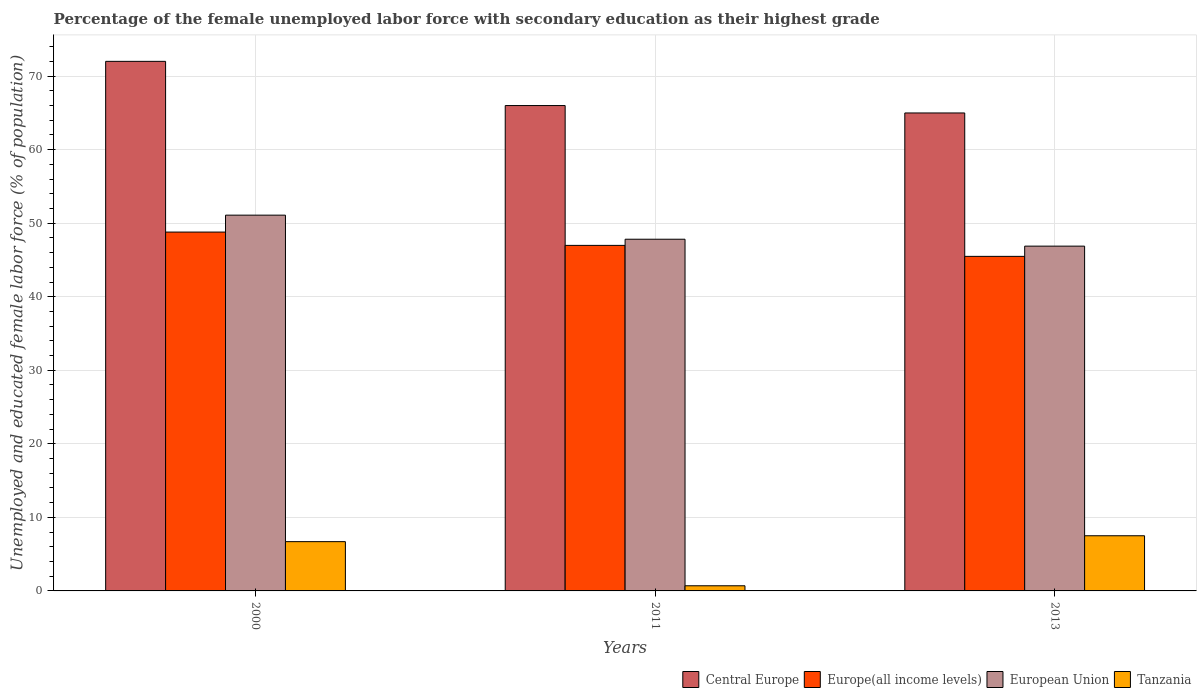How many groups of bars are there?
Ensure brevity in your answer.  3. Are the number of bars per tick equal to the number of legend labels?
Keep it short and to the point. Yes. How many bars are there on the 2nd tick from the left?
Give a very brief answer. 4. How many bars are there on the 1st tick from the right?
Offer a terse response. 4. What is the label of the 3rd group of bars from the left?
Keep it short and to the point. 2013. In how many cases, is the number of bars for a given year not equal to the number of legend labels?
Ensure brevity in your answer.  0. What is the percentage of the unemployed female labor force with secondary education in Tanzania in 2013?
Your response must be concise. 7.5. Across all years, what is the maximum percentage of the unemployed female labor force with secondary education in European Union?
Offer a terse response. 51.09. Across all years, what is the minimum percentage of the unemployed female labor force with secondary education in Tanzania?
Ensure brevity in your answer.  0.7. In which year was the percentage of the unemployed female labor force with secondary education in Europe(all income levels) minimum?
Give a very brief answer. 2013. What is the total percentage of the unemployed female labor force with secondary education in European Union in the graph?
Your answer should be compact. 145.79. What is the difference between the percentage of the unemployed female labor force with secondary education in Central Europe in 2000 and that in 2011?
Your response must be concise. 6.01. What is the difference between the percentage of the unemployed female labor force with secondary education in European Union in 2000 and the percentage of the unemployed female labor force with secondary education in Europe(all income levels) in 2013?
Keep it short and to the point. 5.6. What is the average percentage of the unemployed female labor force with secondary education in Europe(all income levels) per year?
Ensure brevity in your answer.  47.09. In the year 2011, what is the difference between the percentage of the unemployed female labor force with secondary education in Europe(all income levels) and percentage of the unemployed female labor force with secondary education in Central Europe?
Make the answer very short. -19.01. What is the ratio of the percentage of the unemployed female labor force with secondary education in European Union in 2000 to that in 2013?
Your answer should be compact. 1.09. Is the percentage of the unemployed female labor force with secondary education in Tanzania in 2011 less than that in 2013?
Ensure brevity in your answer.  Yes. Is the difference between the percentage of the unemployed female labor force with secondary education in Europe(all income levels) in 2000 and 2011 greater than the difference between the percentage of the unemployed female labor force with secondary education in Central Europe in 2000 and 2011?
Give a very brief answer. No. What is the difference between the highest and the second highest percentage of the unemployed female labor force with secondary education in Europe(all income levels)?
Give a very brief answer. 1.81. What is the difference between the highest and the lowest percentage of the unemployed female labor force with secondary education in European Union?
Your answer should be very brief. 4.21. In how many years, is the percentage of the unemployed female labor force with secondary education in Europe(all income levels) greater than the average percentage of the unemployed female labor force with secondary education in Europe(all income levels) taken over all years?
Provide a short and direct response. 1. Is it the case that in every year, the sum of the percentage of the unemployed female labor force with secondary education in Europe(all income levels) and percentage of the unemployed female labor force with secondary education in Tanzania is greater than the sum of percentage of the unemployed female labor force with secondary education in Central Europe and percentage of the unemployed female labor force with secondary education in European Union?
Offer a terse response. No. What does the 4th bar from the left in 2011 represents?
Your answer should be compact. Tanzania. What does the 1st bar from the right in 2013 represents?
Provide a short and direct response. Tanzania. Are all the bars in the graph horizontal?
Make the answer very short. No. Are the values on the major ticks of Y-axis written in scientific E-notation?
Offer a very short reply. No. Does the graph contain grids?
Provide a short and direct response. Yes. How are the legend labels stacked?
Offer a very short reply. Horizontal. What is the title of the graph?
Provide a short and direct response. Percentage of the female unemployed labor force with secondary education as their highest grade. What is the label or title of the X-axis?
Make the answer very short. Years. What is the label or title of the Y-axis?
Offer a very short reply. Unemployed and educated female labor force (% of population). What is the Unemployed and educated female labor force (% of population) of Central Europe in 2000?
Provide a succinct answer. 72. What is the Unemployed and educated female labor force (% of population) of Europe(all income levels) in 2000?
Offer a terse response. 48.79. What is the Unemployed and educated female labor force (% of population) of European Union in 2000?
Ensure brevity in your answer.  51.09. What is the Unemployed and educated female labor force (% of population) in Tanzania in 2000?
Keep it short and to the point. 6.7. What is the Unemployed and educated female labor force (% of population) of Central Europe in 2011?
Keep it short and to the point. 65.99. What is the Unemployed and educated female labor force (% of population) in Europe(all income levels) in 2011?
Your response must be concise. 46.98. What is the Unemployed and educated female labor force (% of population) of European Union in 2011?
Offer a terse response. 47.82. What is the Unemployed and educated female labor force (% of population) in Tanzania in 2011?
Your answer should be very brief. 0.7. What is the Unemployed and educated female labor force (% of population) in Central Europe in 2013?
Make the answer very short. 64.98. What is the Unemployed and educated female labor force (% of population) of Europe(all income levels) in 2013?
Provide a succinct answer. 45.49. What is the Unemployed and educated female labor force (% of population) in European Union in 2013?
Your answer should be very brief. 46.88. Across all years, what is the maximum Unemployed and educated female labor force (% of population) in Central Europe?
Offer a very short reply. 72. Across all years, what is the maximum Unemployed and educated female labor force (% of population) in Europe(all income levels)?
Provide a succinct answer. 48.79. Across all years, what is the maximum Unemployed and educated female labor force (% of population) in European Union?
Ensure brevity in your answer.  51.09. Across all years, what is the maximum Unemployed and educated female labor force (% of population) in Tanzania?
Provide a succinct answer. 7.5. Across all years, what is the minimum Unemployed and educated female labor force (% of population) in Central Europe?
Give a very brief answer. 64.98. Across all years, what is the minimum Unemployed and educated female labor force (% of population) of Europe(all income levels)?
Offer a terse response. 45.49. Across all years, what is the minimum Unemployed and educated female labor force (% of population) of European Union?
Provide a short and direct response. 46.88. Across all years, what is the minimum Unemployed and educated female labor force (% of population) of Tanzania?
Provide a succinct answer. 0.7. What is the total Unemployed and educated female labor force (% of population) in Central Europe in the graph?
Your answer should be very brief. 202.98. What is the total Unemployed and educated female labor force (% of population) of Europe(all income levels) in the graph?
Your answer should be compact. 141.26. What is the total Unemployed and educated female labor force (% of population) in European Union in the graph?
Offer a terse response. 145.79. What is the total Unemployed and educated female labor force (% of population) in Tanzania in the graph?
Keep it short and to the point. 14.9. What is the difference between the Unemployed and educated female labor force (% of population) in Central Europe in 2000 and that in 2011?
Give a very brief answer. 6.01. What is the difference between the Unemployed and educated female labor force (% of population) of Europe(all income levels) in 2000 and that in 2011?
Offer a very short reply. 1.81. What is the difference between the Unemployed and educated female labor force (% of population) in European Union in 2000 and that in 2011?
Your answer should be compact. 3.27. What is the difference between the Unemployed and educated female labor force (% of population) of Central Europe in 2000 and that in 2013?
Offer a very short reply. 7.02. What is the difference between the Unemployed and educated female labor force (% of population) of Europe(all income levels) in 2000 and that in 2013?
Provide a succinct answer. 3.3. What is the difference between the Unemployed and educated female labor force (% of population) of European Union in 2000 and that in 2013?
Make the answer very short. 4.21. What is the difference between the Unemployed and educated female labor force (% of population) in Tanzania in 2000 and that in 2013?
Provide a short and direct response. -0.8. What is the difference between the Unemployed and educated female labor force (% of population) in Europe(all income levels) in 2011 and that in 2013?
Your response must be concise. 1.49. What is the difference between the Unemployed and educated female labor force (% of population) of European Union in 2011 and that in 2013?
Offer a very short reply. 0.94. What is the difference between the Unemployed and educated female labor force (% of population) of Tanzania in 2011 and that in 2013?
Provide a short and direct response. -6.8. What is the difference between the Unemployed and educated female labor force (% of population) of Central Europe in 2000 and the Unemployed and educated female labor force (% of population) of Europe(all income levels) in 2011?
Your answer should be compact. 25.02. What is the difference between the Unemployed and educated female labor force (% of population) in Central Europe in 2000 and the Unemployed and educated female labor force (% of population) in European Union in 2011?
Give a very brief answer. 24.18. What is the difference between the Unemployed and educated female labor force (% of population) in Central Europe in 2000 and the Unemployed and educated female labor force (% of population) in Tanzania in 2011?
Offer a very short reply. 71.3. What is the difference between the Unemployed and educated female labor force (% of population) of Europe(all income levels) in 2000 and the Unemployed and educated female labor force (% of population) of European Union in 2011?
Keep it short and to the point. 0.97. What is the difference between the Unemployed and educated female labor force (% of population) in Europe(all income levels) in 2000 and the Unemployed and educated female labor force (% of population) in Tanzania in 2011?
Keep it short and to the point. 48.09. What is the difference between the Unemployed and educated female labor force (% of population) of European Union in 2000 and the Unemployed and educated female labor force (% of population) of Tanzania in 2011?
Your response must be concise. 50.39. What is the difference between the Unemployed and educated female labor force (% of population) in Central Europe in 2000 and the Unemployed and educated female labor force (% of population) in Europe(all income levels) in 2013?
Make the answer very short. 26.51. What is the difference between the Unemployed and educated female labor force (% of population) of Central Europe in 2000 and the Unemployed and educated female labor force (% of population) of European Union in 2013?
Provide a succinct answer. 25.12. What is the difference between the Unemployed and educated female labor force (% of population) of Central Europe in 2000 and the Unemployed and educated female labor force (% of population) of Tanzania in 2013?
Ensure brevity in your answer.  64.5. What is the difference between the Unemployed and educated female labor force (% of population) in Europe(all income levels) in 2000 and the Unemployed and educated female labor force (% of population) in European Union in 2013?
Ensure brevity in your answer.  1.91. What is the difference between the Unemployed and educated female labor force (% of population) of Europe(all income levels) in 2000 and the Unemployed and educated female labor force (% of population) of Tanzania in 2013?
Offer a terse response. 41.29. What is the difference between the Unemployed and educated female labor force (% of population) of European Union in 2000 and the Unemployed and educated female labor force (% of population) of Tanzania in 2013?
Provide a short and direct response. 43.59. What is the difference between the Unemployed and educated female labor force (% of population) of Central Europe in 2011 and the Unemployed and educated female labor force (% of population) of Europe(all income levels) in 2013?
Your response must be concise. 20.5. What is the difference between the Unemployed and educated female labor force (% of population) in Central Europe in 2011 and the Unemployed and educated female labor force (% of population) in European Union in 2013?
Your answer should be very brief. 19.11. What is the difference between the Unemployed and educated female labor force (% of population) in Central Europe in 2011 and the Unemployed and educated female labor force (% of population) in Tanzania in 2013?
Provide a succinct answer. 58.49. What is the difference between the Unemployed and educated female labor force (% of population) of Europe(all income levels) in 2011 and the Unemployed and educated female labor force (% of population) of European Union in 2013?
Offer a very short reply. 0.1. What is the difference between the Unemployed and educated female labor force (% of population) in Europe(all income levels) in 2011 and the Unemployed and educated female labor force (% of population) in Tanzania in 2013?
Your answer should be compact. 39.48. What is the difference between the Unemployed and educated female labor force (% of population) in European Union in 2011 and the Unemployed and educated female labor force (% of population) in Tanzania in 2013?
Offer a terse response. 40.32. What is the average Unemployed and educated female labor force (% of population) in Central Europe per year?
Provide a short and direct response. 67.66. What is the average Unemployed and educated female labor force (% of population) of Europe(all income levels) per year?
Ensure brevity in your answer.  47.09. What is the average Unemployed and educated female labor force (% of population) of European Union per year?
Offer a terse response. 48.6. What is the average Unemployed and educated female labor force (% of population) in Tanzania per year?
Ensure brevity in your answer.  4.97. In the year 2000, what is the difference between the Unemployed and educated female labor force (% of population) in Central Europe and Unemployed and educated female labor force (% of population) in Europe(all income levels)?
Provide a succinct answer. 23.21. In the year 2000, what is the difference between the Unemployed and educated female labor force (% of population) in Central Europe and Unemployed and educated female labor force (% of population) in European Union?
Your answer should be compact. 20.91. In the year 2000, what is the difference between the Unemployed and educated female labor force (% of population) of Central Europe and Unemployed and educated female labor force (% of population) of Tanzania?
Make the answer very short. 65.3. In the year 2000, what is the difference between the Unemployed and educated female labor force (% of population) in Europe(all income levels) and Unemployed and educated female labor force (% of population) in European Union?
Offer a terse response. -2.3. In the year 2000, what is the difference between the Unemployed and educated female labor force (% of population) in Europe(all income levels) and Unemployed and educated female labor force (% of population) in Tanzania?
Keep it short and to the point. 42.09. In the year 2000, what is the difference between the Unemployed and educated female labor force (% of population) in European Union and Unemployed and educated female labor force (% of population) in Tanzania?
Your answer should be compact. 44.39. In the year 2011, what is the difference between the Unemployed and educated female labor force (% of population) of Central Europe and Unemployed and educated female labor force (% of population) of Europe(all income levels)?
Your response must be concise. 19.01. In the year 2011, what is the difference between the Unemployed and educated female labor force (% of population) in Central Europe and Unemployed and educated female labor force (% of population) in European Union?
Provide a succinct answer. 18.17. In the year 2011, what is the difference between the Unemployed and educated female labor force (% of population) of Central Europe and Unemployed and educated female labor force (% of population) of Tanzania?
Make the answer very short. 65.29. In the year 2011, what is the difference between the Unemployed and educated female labor force (% of population) in Europe(all income levels) and Unemployed and educated female labor force (% of population) in European Union?
Offer a very short reply. -0.84. In the year 2011, what is the difference between the Unemployed and educated female labor force (% of population) of Europe(all income levels) and Unemployed and educated female labor force (% of population) of Tanzania?
Offer a terse response. 46.28. In the year 2011, what is the difference between the Unemployed and educated female labor force (% of population) of European Union and Unemployed and educated female labor force (% of population) of Tanzania?
Your response must be concise. 47.12. In the year 2013, what is the difference between the Unemployed and educated female labor force (% of population) of Central Europe and Unemployed and educated female labor force (% of population) of Europe(all income levels)?
Ensure brevity in your answer.  19.5. In the year 2013, what is the difference between the Unemployed and educated female labor force (% of population) of Central Europe and Unemployed and educated female labor force (% of population) of European Union?
Make the answer very short. 18.11. In the year 2013, what is the difference between the Unemployed and educated female labor force (% of population) of Central Europe and Unemployed and educated female labor force (% of population) of Tanzania?
Provide a short and direct response. 57.48. In the year 2013, what is the difference between the Unemployed and educated female labor force (% of population) in Europe(all income levels) and Unemployed and educated female labor force (% of population) in European Union?
Offer a very short reply. -1.39. In the year 2013, what is the difference between the Unemployed and educated female labor force (% of population) of Europe(all income levels) and Unemployed and educated female labor force (% of population) of Tanzania?
Offer a very short reply. 37.99. In the year 2013, what is the difference between the Unemployed and educated female labor force (% of population) of European Union and Unemployed and educated female labor force (% of population) of Tanzania?
Provide a succinct answer. 39.38. What is the ratio of the Unemployed and educated female labor force (% of population) in Central Europe in 2000 to that in 2011?
Your answer should be compact. 1.09. What is the ratio of the Unemployed and educated female labor force (% of population) in European Union in 2000 to that in 2011?
Provide a succinct answer. 1.07. What is the ratio of the Unemployed and educated female labor force (% of population) of Tanzania in 2000 to that in 2011?
Offer a very short reply. 9.57. What is the ratio of the Unemployed and educated female labor force (% of population) of Central Europe in 2000 to that in 2013?
Your answer should be compact. 1.11. What is the ratio of the Unemployed and educated female labor force (% of population) in Europe(all income levels) in 2000 to that in 2013?
Ensure brevity in your answer.  1.07. What is the ratio of the Unemployed and educated female labor force (% of population) in European Union in 2000 to that in 2013?
Your response must be concise. 1.09. What is the ratio of the Unemployed and educated female labor force (% of population) in Tanzania in 2000 to that in 2013?
Make the answer very short. 0.89. What is the ratio of the Unemployed and educated female labor force (% of population) in Central Europe in 2011 to that in 2013?
Give a very brief answer. 1.02. What is the ratio of the Unemployed and educated female labor force (% of population) of Europe(all income levels) in 2011 to that in 2013?
Ensure brevity in your answer.  1.03. What is the ratio of the Unemployed and educated female labor force (% of population) of European Union in 2011 to that in 2013?
Your answer should be very brief. 1.02. What is the ratio of the Unemployed and educated female labor force (% of population) in Tanzania in 2011 to that in 2013?
Your response must be concise. 0.09. What is the difference between the highest and the second highest Unemployed and educated female labor force (% of population) in Central Europe?
Your answer should be compact. 6.01. What is the difference between the highest and the second highest Unemployed and educated female labor force (% of population) of Europe(all income levels)?
Ensure brevity in your answer.  1.81. What is the difference between the highest and the second highest Unemployed and educated female labor force (% of population) in European Union?
Give a very brief answer. 3.27. What is the difference between the highest and the lowest Unemployed and educated female labor force (% of population) of Central Europe?
Offer a very short reply. 7.02. What is the difference between the highest and the lowest Unemployed and educated female labor force (% of population) in Europe(all income levels)?
Make the answer very short. 3.3. What is the difference between the highest and the lowest Unemployed and educated female labor force (% of population) in European Union?
Provide a succinct answer. 4.21. What is the difference between the highest and the lowest Unemployed and educated female labor force (% of population) in Tanzania?
Give a very brief answer. 6.8. 